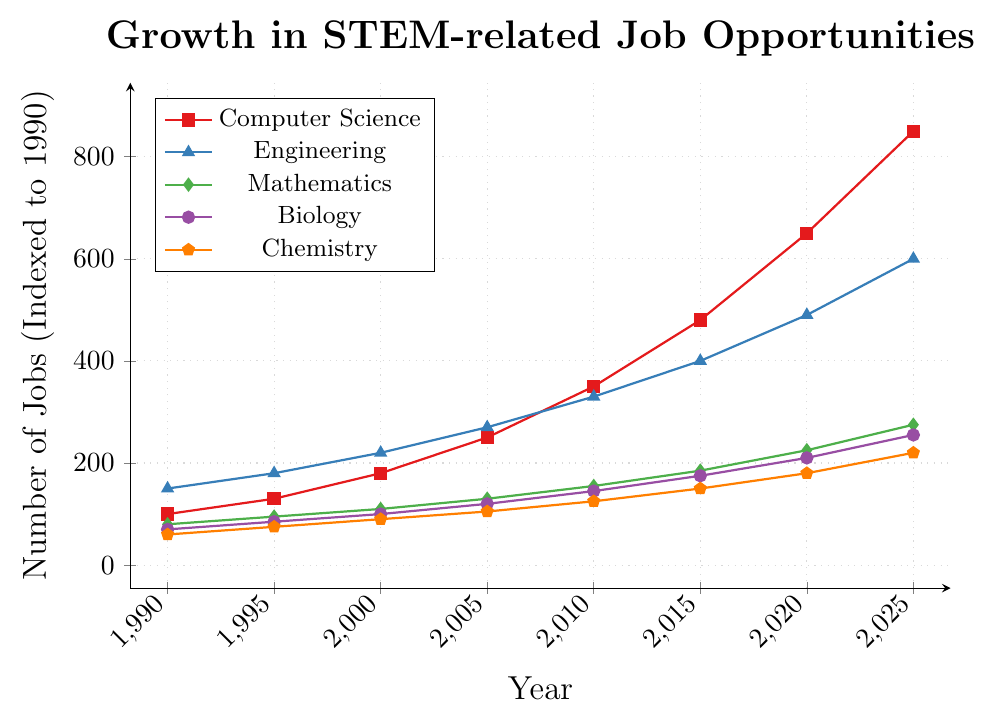What discipline experienced the most significant growth between 1990 and 2025? The Computer Science category shows the highest growth, starting at 100 in 1990 and reaching 850 in 2025. By comparing the initial and final values for each discipline, we can confirm that Computer Science has the largest increase (850 - 100 = 750).
Answer: Computer Science Which discipline had the lowest job opportunities in 2010? To find this, let's look at the 2010 data points. Chemistry had 125, Biology had 145, Mathematics had 155, Engineering had 330, and Computer Science had 350. Thus, Chemistry has the lowest number of job opportunities in 2010.
Answer: Chemistry What is the total number of job opportunities in Mathematics and Biology combined in the year 2020? Looking at the data for 2020, Mathematics has 225 job opportunities, and Biology has 210. Adding them together, 225 + 210 = 435.
Answer: 435 How much did Engineering job opportunities grow from 1990 to 2005? In 1990, Engineering had 150 job opportunities. By 2005, this number had risen to 270. The growth is 270 - 150 = 120.
Answer: 120 Which discipline saw the greatest growth between 2010 and 2015? Computer Science went from 350 to 480, growing by 130. Engineering rose from 330 to 400, gaining 70. Mathematics increased from 155 to 185 (30), Biology from 145 to 175 (30), and Chemistry from 125 to 150 (25). Thus, Computer Science had the greatest growth (130).
Answer: Computer Science In which year did Biology and Chemistry have an equal number of job opportunities? Looking at the numbers for each year, we see that Biology and Chemistry both have different numbers in every year listed. Thus, there isn't a year where Biology and Chemistry had an equal number of job opportunities.
Answer: None What was the difference in the number of job opportunities between Mathematics and Engineering in 2025? In 2025, Mathematics had 275 job opportunities, and Engineering had 600. The difference is 600 - 275 = 325.
Answer: 325 Which discipline had the steadiest growth based on the visual information? By examining the plot visually, Mathematics and Chemistry display a steady and consistent growth line without sharp increases or decreases. Out of these, Mathematics shows the steadiest growth.
Answer: Mathematics 